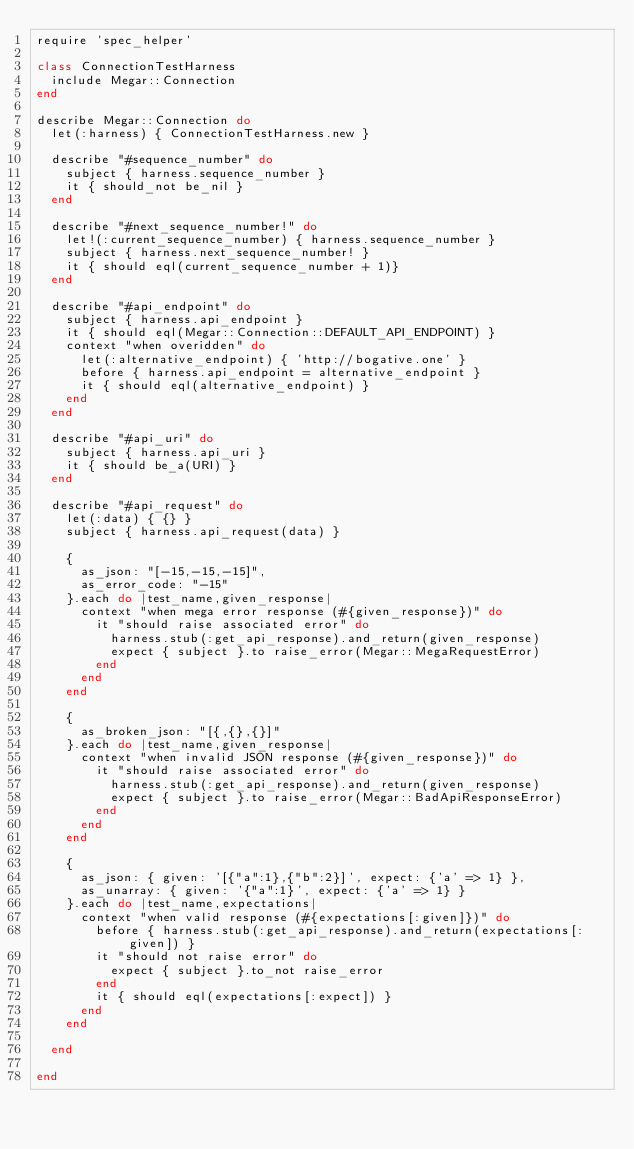Convert code to text. <code><loc_0><loc_0><loc_500><loc_500><_Ruby_>require 'spec_helper'

class ConnectionTestHarness
  include Megar::Connection
end

describe Megar::Connection do
  let(:harness) { ConnectionTestHarness.new }

  describe "#sequence_number" do
    subject { harness.sequence_number }
    it { should_not be_nil }
  end

  describe "#next_sequence_number!" do
    let!(:current_sequence_number) { harness.sequence_number }
    subject { harness.next_sequence_number! }
    it { should eql(current_sequence_number + 1)}
  end

  describe "#api_endpoint" do
    subject { harness.api_endpoint }
    it { should eql(Megar::Connection::DEFAULT_API_ENDPOINT) }
    context "when overidden" do
      let(:alternative_endpoint) { 'http://bogative.one' }
      before { harness.api_endpoint = alternative_endpoint }
      it { should eql(alternative_endpoint) }
    end
  end

  describe "#api_uri" do
    subject { harness.api_uri }
    it { should be_a(URI) }
  end

  describe "#api_request" do
    let(:data) { {} }
    subject { harness.api_request(data) }

    {
      as_json: "[-15,-15,-15]",
      as_error_code: "-15"
    }.each do |test_name,given_response|
      context "when mega error response (#{given_response})" do
        it "should raise associated error" do
          harness.stub(:get_api_response).and_return(given_response)
          expect { subject }.to raise_error(Megar::MegaRequestError)
        end
      end
    end

    {
      as_broken_json: "[{,{},{}]"
    }.each do |test_name,given_response|
      context "when invalid JSON response (#{given_response})" do
        it "should raise associated error" do
          harness.stub(:get_api_response).and_return(given_response)
          expect { subject }.to raise_error(Megar::BadApiResponseError)
        end
      end
    end

    {
      as_json: { given: '[{"a":1},{"b":2}]', expect: {'a' => 1} },
      as_unarray: { given: '{"a":1}', expect: {'a' => 1} }
    }.each do |test_name,expectations|
      context "when valid response (#{expectations[:given]})" do
        before { harness.stub(:get_api_response).and_return(expectations[:given]) }
        it "should not raise error" do
          expect { subject }.to_not raise_error
        end
        it { should eql(expectations[:expect]) }
      end
    end

  end

end

</code> 